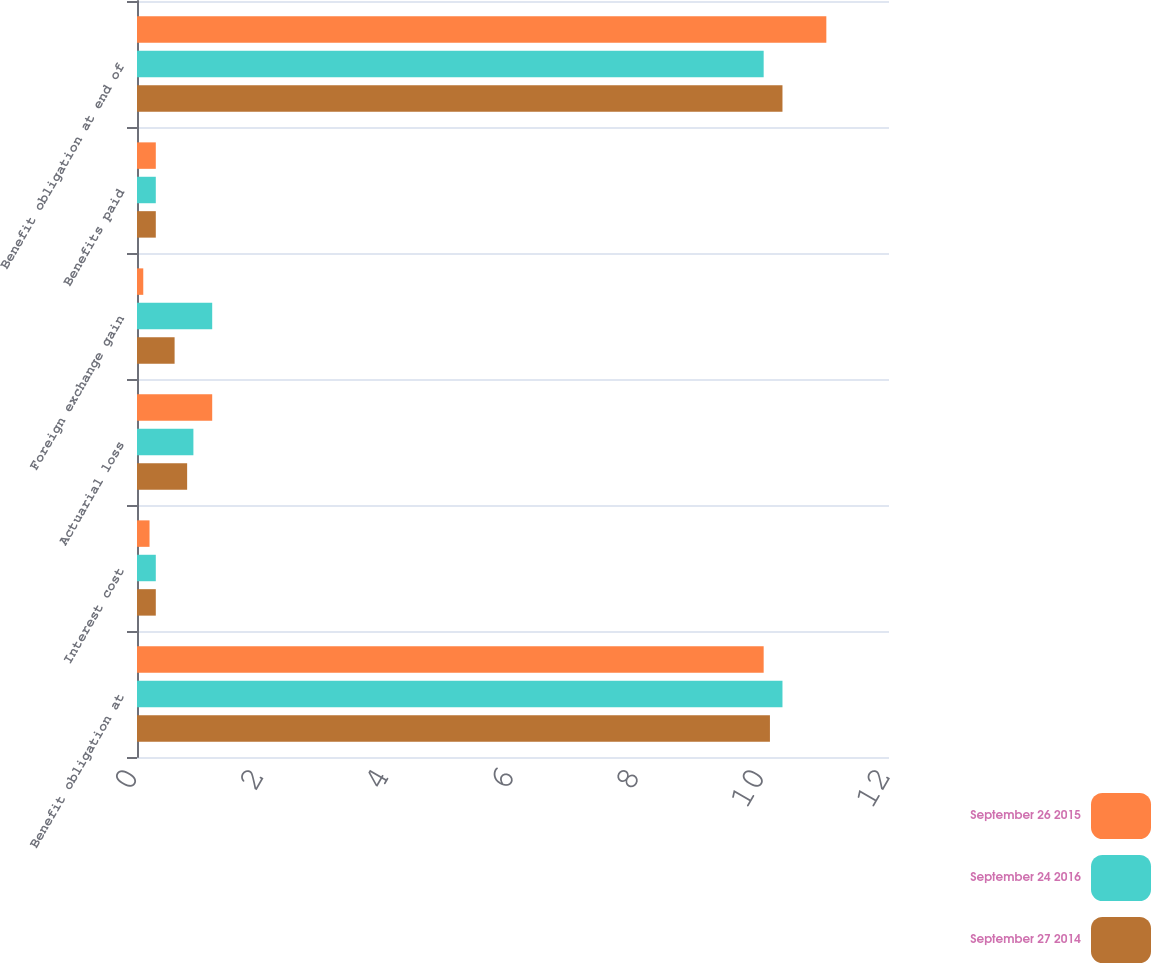Convert chart. <chart><loc_0><loc_0><loc_500><loc_500><stacked_bar_chart><ecel><fcel>Benefit obligation at<fcel>Interest cost<fcel>Actuarial loss<fcel>Foreign exchange gain<fcel>Benefits paid<fcel>Benefit obligation at end of<nl><fcel>September 26 2015<fcel>10<fcel>0.2<fcel>1.2<fcel>0.1<fcel>0.3<fcel>11<nl><fcel>September 24 2016<fcel>10.3<fcel>0.3<fcel>0.9<fcel>1.2<fcel>0.3<fcel>10<nl><fcel>September 27 2014<fcel>10.1<fcel>0.3<fcel>0.8<fcel>0.6<fcel>0.3<fcel>10.3<nl></chart> 